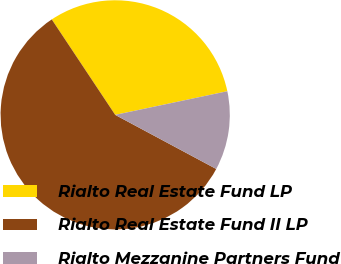Convert chart to OTSL. <chart><loc_0><loc_0><loc_500><loc_500><pie_chart><fcel>Rialto Real Estate Fund LP<fcel>Rialto Real Estate Fund II LP<fcel>Rialto Mezzanine Partners Fund<nl><fcel>31.03%<fcel>57.84%<fcel>11.13%<nl></chart> 